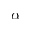Convert formula to latex. <formula><loc_0><loc_0><loc_500><loc_500>\alpha</formula> 